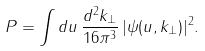<formula> <loc_0><loc_0><loc_500><loc_500>P = \int d u \, \frac { d ^ { 2 } k _ { \perp } } { 1 6 \pi ^ { 3 } } \, | \psi ( u , k _ { \perp } ) | ^ { 2 } .</formula> 